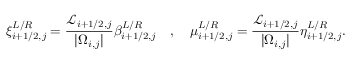<formula> <loc_0><loc_0><loc_500><loc_500>\xi _ { i + 1 / 2 , j } ^ { L / R } = \frac { \mathcal { L } _ { i + 1 / 2 , j } } { | \Omega _ { i , j } | } \beta _ { i + 1 / 2 , j } ^ { L / R } \quad , \quad \mu _ { i + 1 / 2 , j } ^ { L / R } = \frac { \mathcal { L } _ { i + 1 / 2 , j } } { | \Omega _ { i , j } | } \eta _ { i + 1 / 2 , j } ^ { L / R } .</formula> 